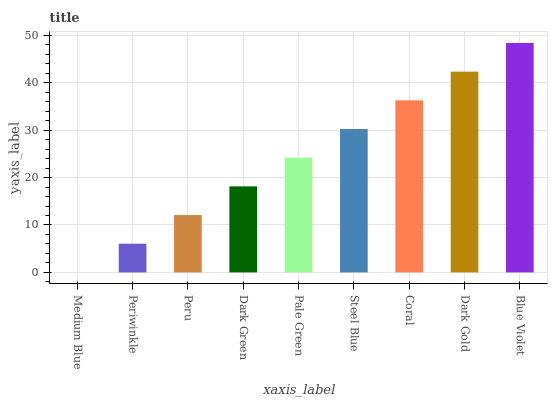Is Medium Blue the minimum?
Answer yes or no. Yes. Is Blue Violet the maximum?
Answer yes or no. Yes. Is Periwinkle the minimum?
Answer yes or no. No. Is Periwinkle the maximum?
Answer yes or no. No. Is Periwinkle greater than Medium Blue?
Answer yes or no. Yes. Is Medium Blue less than Periwinkle?
Answer yes or no. Yes. Is Medium Blue greater than Periwinkle?
Answer yes or no. No. Is Periwinkle less than Medium Blue?
Answer yes or no. No. Is Pale Green the high median?
Answer yes or no. Yes. Is Pale Green the low median?
Answer yes or no. Yes. Is Blue Violet the high median?
Answer yes or no. No. Is Peru the low median?
Answer yes or no. No. 